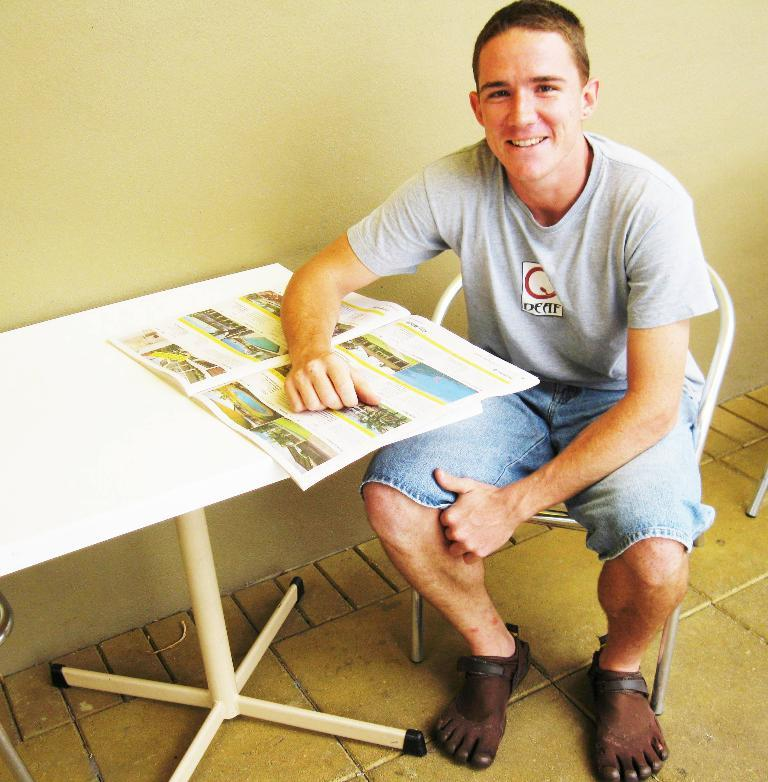Who is present in the image? There is a man in the image. What is the man doing in the image? The man is sitting in a chair. What object can be seen on the table in the image? There is a book on the table. What is the man's facial expression in the image? The man is smiling. What color is the wall in the image? The wall is painted light yellow. What level of experience does the man have in space exploration in the image? There is no indication of space exploration or experience levels in the image. 